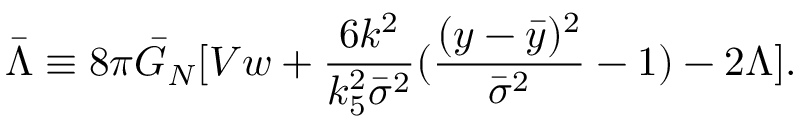Convert formula to latex. <formula><loc_0><loc_0><loc_500><loc_500>\bar { \Lambda } \equiv 8 \pi \bar { G } _ { N } [ V w + \frac { 6 k ^ { 2 } } { k _ { 5 } ^ { 2 } \bar { \sigma } ^ { 2 } } ( \frac { ( y - \bar { y } ) ^ { 2 } } { \bar { \sigma } ^ { 2 } } - 1 ) - 2 \Lambda ] .</formula> 